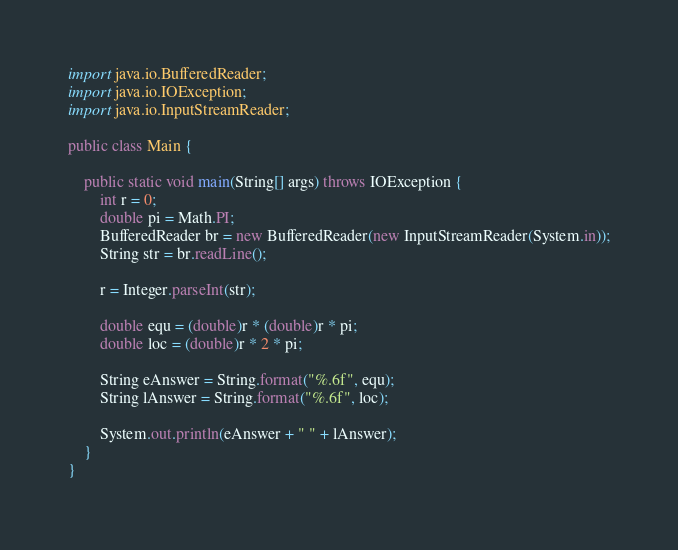<code> <loc_0><loc_0><loc_500><loc_500><_Java_>import java.io.BufferedReader;
import java.io.IOException;
import java.io.InputStreamReader;

public class Main {

	public static void main(String[] args) throws IOException {
		int r = 0;
		double pi = Math.PI;
		BufferedReader br = new BufferedReader(new InputStreamReader(System.in));
		String str = br.readLine();
		
		r = Integer.parseInt(str);
		
		double equ = (double)r * (double)r * pi; 
		double loc = (double)r * 2 * pi;
		
		String eAnswer = String.format("%.6f", equ);
		String lAnswer = String.format("%.6f", loc);
		
		System.out.println(eAnswer + " " + lAnswer);
	}
}</code> 